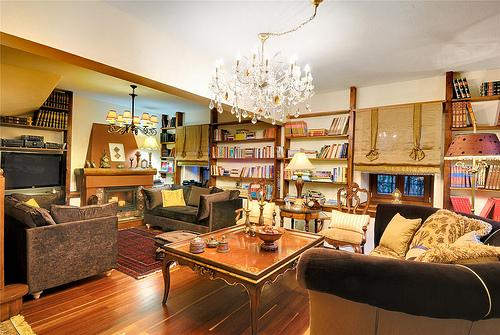Which object sits on the floor of the living room? A small red carpet sits on the wooden floor of the living room. Identify the most prominent appliance in the image. The most prominent appliance in the image is the television, which is tucked on a bookshelf. What is the predominant color in the image? White is the predominant color in the image, which is mainly seen in the ceiling. How many types of furniture are there in the image, and what are they? There are four types of furniture in the image: a large sofa, a coffee table, a circular table, and a wooden chair. Describe the lighting condition in the room. The room is well-lit, with a chandelier hanging from the ceiling, several lamps placed around the room, and ample natural light coming from the window. What do the bookshelves in the image primarily contain? The bookshelves primarily contain many books. What objects are located in front of the window? The objects located in front of the window include a brown curtain and a table with a lamp on it. Provide a list of objects found in the room. Objects found in the room include a chandelier, red carpet, bookshelves, fireplace, television, coffee table, sofa, reading lamp, table lamp, window, chair, and a variety of pillows. What is the color of the chandelier? The chandelier is made from crystal, giving it a transparent appearance. Enumerate three decorative items found in the room. Three decorative items found in the room are the chandelier, table lamps, and the window covering. What event is occurring near the fireplace? There is no specific event happening near the fireplace. What kind of floor does the room have? Wooden floor What style of covering is on the window? Bamboo shades and brown curtain Identify the object hanging from the ceiling. A crystal chandelier Explain the window's appearance in the image. The window is mostly hidden behind brown curtains and bamboo shades. What is on top of the bookshelves? Many books and a television Which statement is true about the room? a) dark and gloomy b) well lighted c) medium-light B) Well lighted Which item has dots on it? The reading lamp next to the large sofa What objects are on the shelves in the image? Books and a television Describe the coffee table in the room. The coffee table is in the center of the room, in front of the large sofa, and has a glossy surface. Describe the appearance of the lamp on the circular table. The table lamp has a white shade. What color is the carpet in the room? Red Describe the cushions on the large sofa. Soft, sagging, white and gold pillows Explain the details of the television's location. The television is tucked on a bookshelf. What expression is displayed on the pillow on the sofa? There is no facial expression on the pillow. List the main components visible in the photograph. Chandelier, rug, coffee table, television, fireplace, curtains, books, pillows, chairs, and lamps What is the main activity happening in the described image? No specific activity, it is an image of a living room. State the appearance: a) brown couch b) green chair c) black sofa A) Brown couch Describe the fireplace in the room. The fireplace is on the wall, warming the room. What material are the chairs in the living room made from? Wooden 